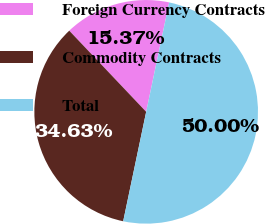Convert chart. <chart><loc_0><loc_0><loc_500><loc_500><pie_chart><fcel>Foreign Currency Contracts<fcel>Commodity Contracts<fcel>Total<nl><fcel>15.37%<fcel>34.63%<fcel>50.0%<nl></chart> 